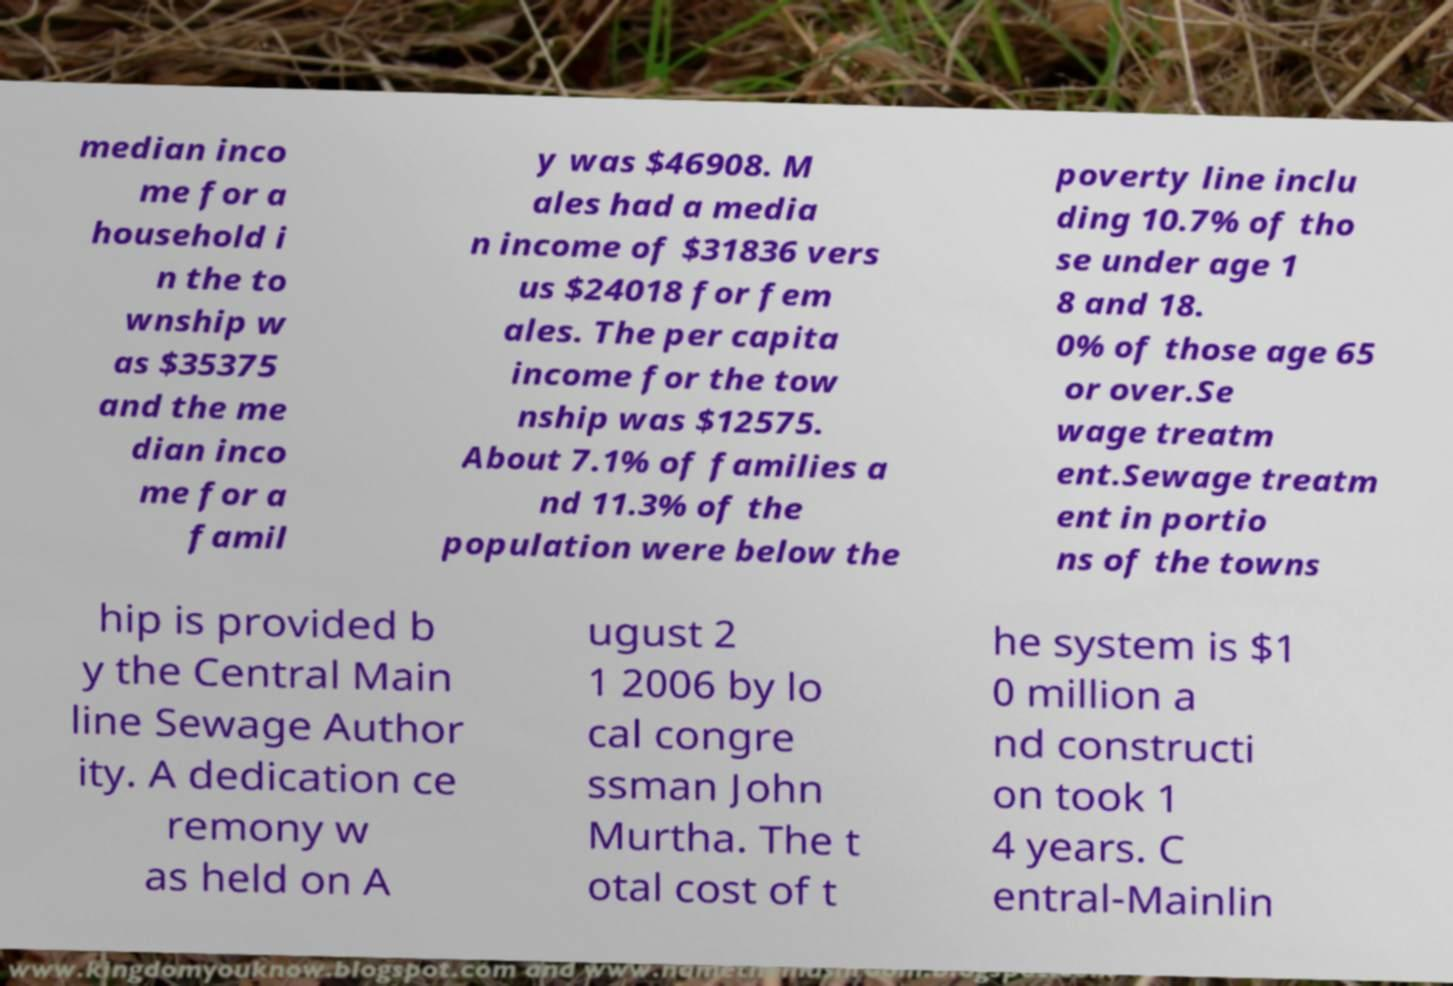Please identify and transcribe the text found in this image. median inco me for a household i n the to wnship w as $35375 and the me dian inco me for a famil y was $46908. M ales had a media n income of $31836 vers us $24018 for fem ales. The per capita income for the tow nship was $12575. About 7.1% of families a nd 11.3% of the population were below the poverty line inclu ding 10.7% of tho se under age 1 8 and 18. 0% of those age 65 or over.Se wage treatm ent.Sewage treatm ent in portio ns of the towns hip is provided b y the Central Main line Sewage Author ity. A dedication ce remony w as held on A ugust 2 1 2006 by lo cal congre ssman John Murtha. The t otal cost of t he system is $1 0 million a nd constructi on took 1 4 years. C entral-Mainlin 